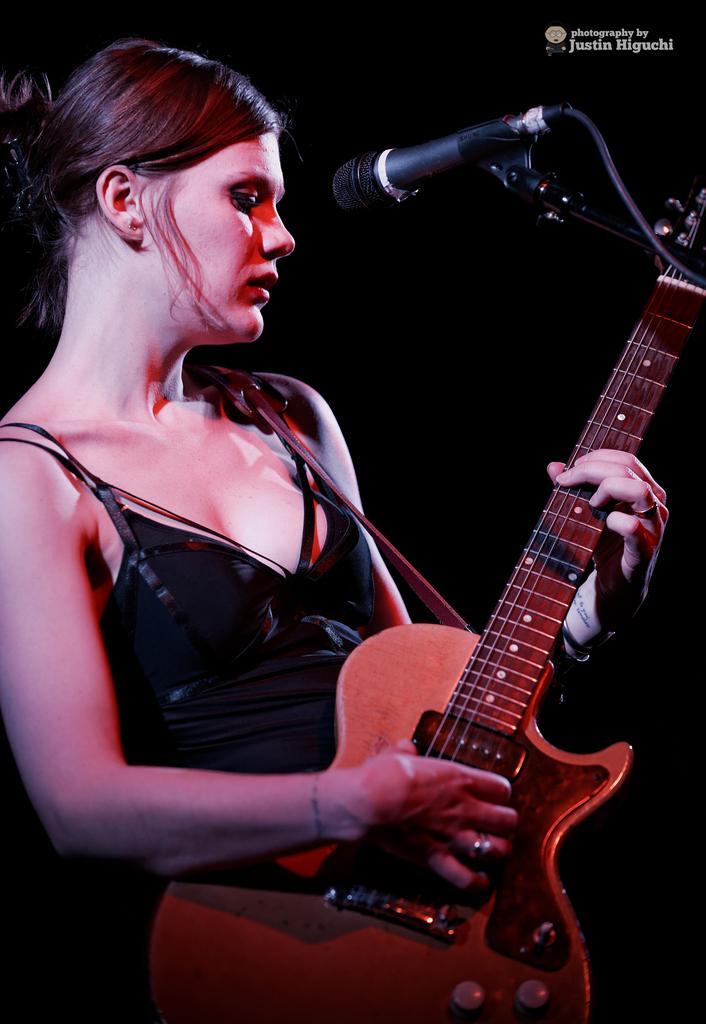How would you summarize this image in a sentence or two? In the center we can see lady she is holding guitar. In front of her we can see the microphone. 